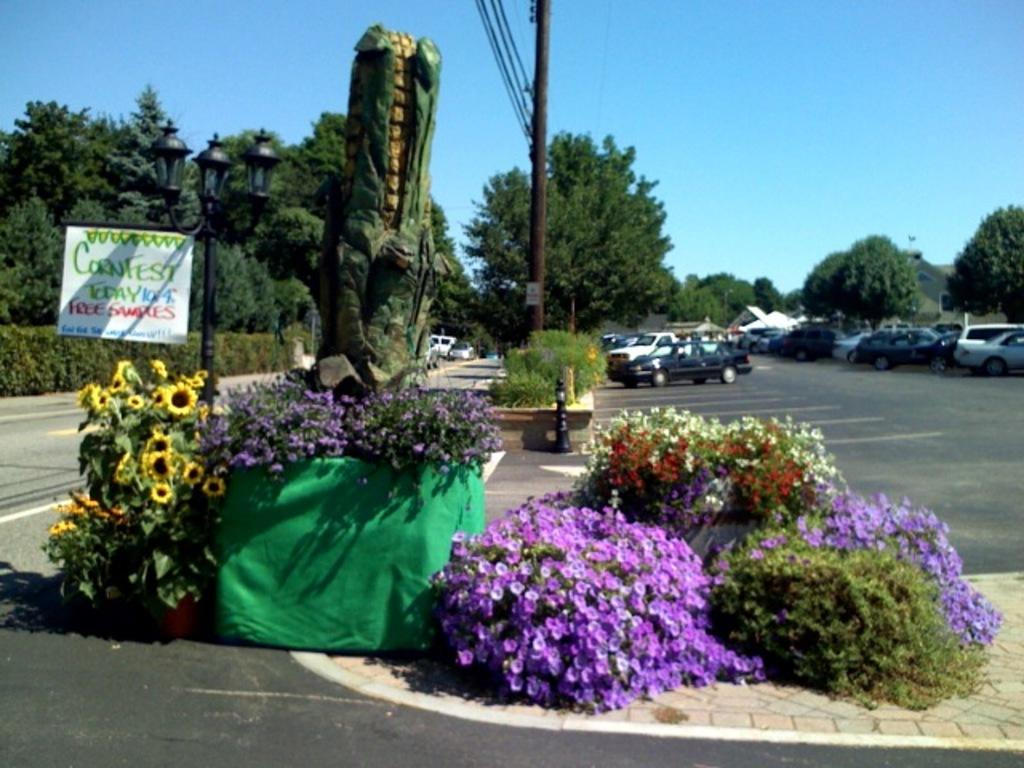What type of living organisms can be seen in the image? Flowers and plants are visible in the image. What object in the image might indicate a location or name? There is a name board in the image. What can be seen in the background of the image? Poles, cars, trees, lights, and houses are visible in the background. What type of fruit is hanging from the quince tree in the image? There is no quince tree present in the image, and therefore no such fruit can be observed. What type of art can be seen on the walls in the image? There is no art visible on the walls in the image. 